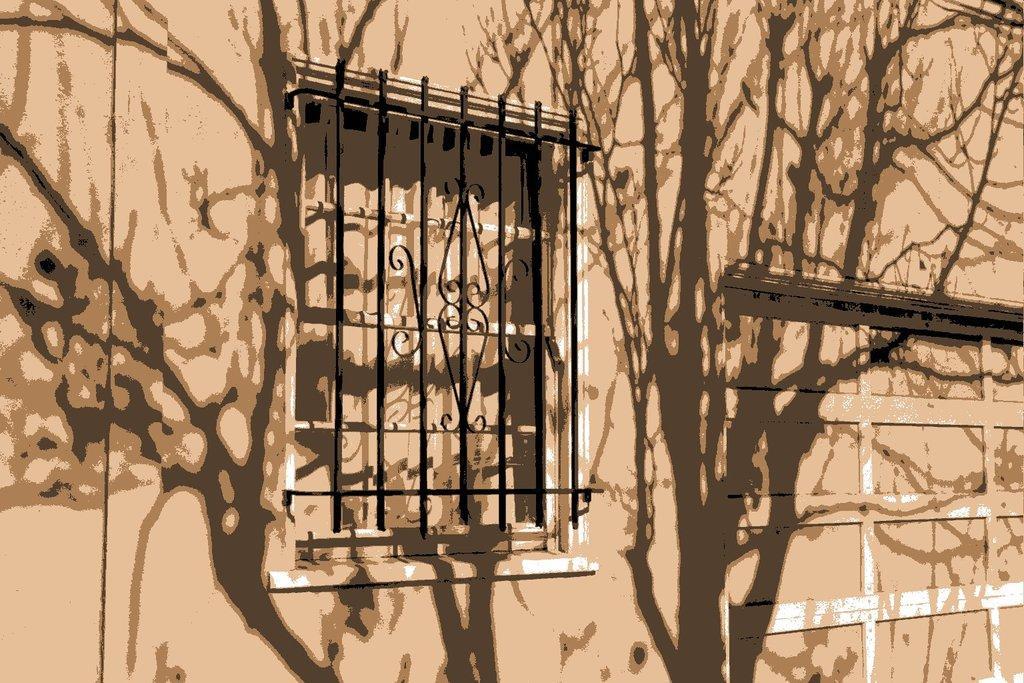Please provide a concise description of this image. In this image we can see an edited picture of a building with windows, metal fence, door. 